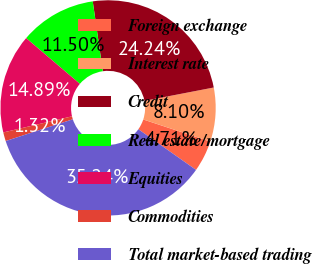<chart> <loc_0><loc_0><loc_500><loc_500><pie_chart><fcel>Foreign exchange<fcel>Interest rate<fcel>Credit<fcel>Real estate/mortgage<fcel>Equities<fcel>Commodities<fcel>Total market-based trading<nl><fcel>4.71%<fcel>8.1%<fcel>24.24%<fcel>11.5%<fcel>14.89%<fcel>1.32%<fcel>35.24%<nl></chart> 